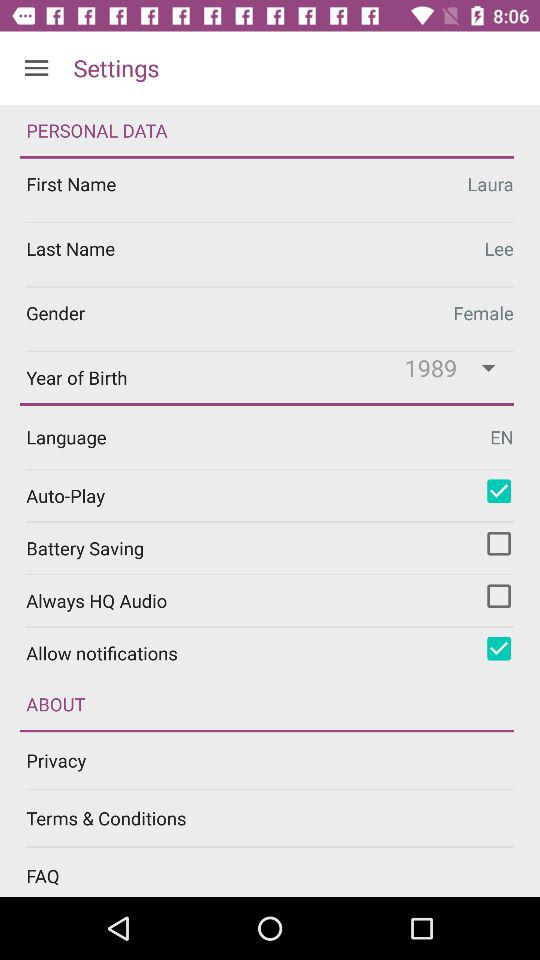What is the gender of the user? The gender of the user is female. 